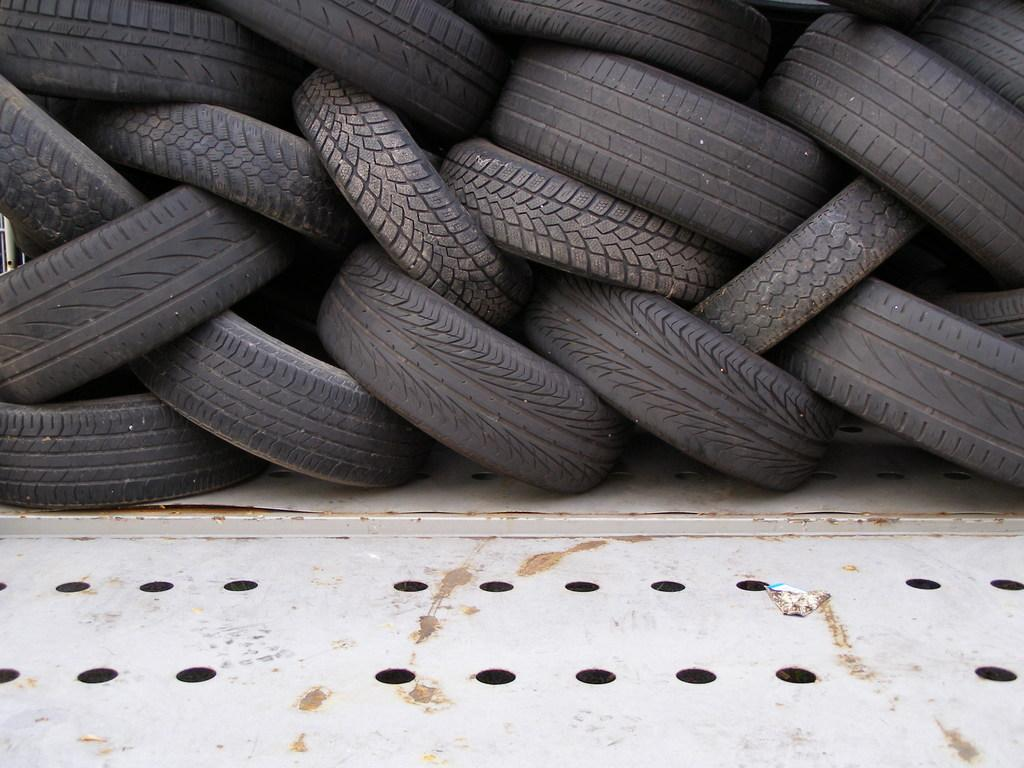What is located in the center of the image? There are tyres in the center of the image. How many feet can be seen supporting the tyres in the image? There are no feet visible in the image, as it features tyres in the center and does not show any supporting structures. 